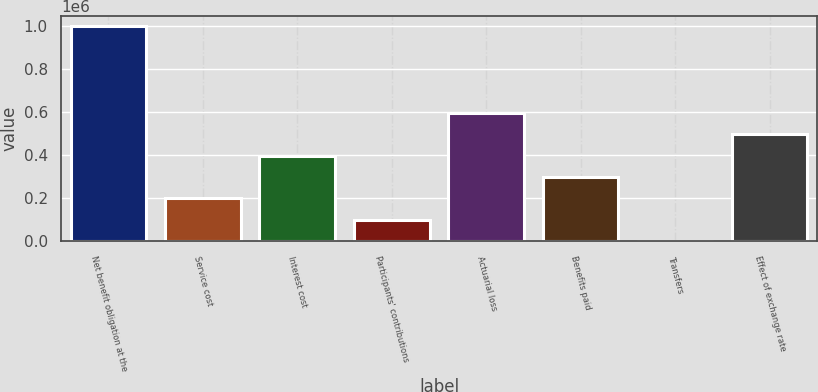Convert chart to OTSL. <chart><loc_0><loc_0><loc_500><loc_500><bar_chart><fcel>Net benefit obligation at the<fcel>Service cost<fcel>Interest cost<fcel>Participants' contributions<fcel>Actuarial loss<fcel>Benefits paid<fcel>Transfers<fcel>Effect of exchange rate<nl><fcel>997262<fcel>199377<fcel>397398<fcel>100366<fcel>595418<fcel>298387<fcel>1356<fcel>496408<nl></chart> 